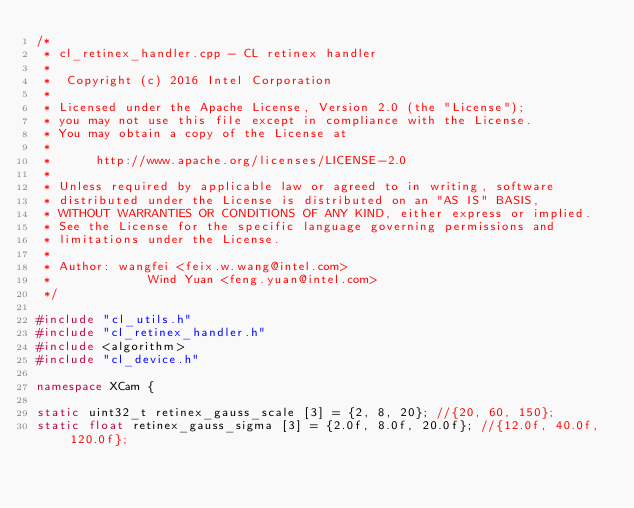<code> <loc_0><loc_0><loc_500><loc_500><_C++_>/*
 * cl_retinex_handler.cpp - CL retinex handler
 *
 *  Copyright (c) 2016 Intel Corporation
 *
 * Licensed under the Apache License, Version 2.0 (the "License");
 * you may not use this file except in compliance with the License.
 * You may obtain a copy of the License at
 *
 *      http://www.apache.org/licenses/LICENSE-2.0
 *
 * Unless required by applicable law or agreed to in writing, software
 * distributed under the License is distributed on an "AS IS" BASIS,
 * WITHOUT WARRANTIES OR CONDITIONS OF ANY KIND, either express or implied.
 * See the License for the specific language governing permissions and
 * limitations under the License.
 *
 * Author: wangfei <feix.w.wang@intel.com>
 *             Wind Yuan <feng.yuan@intel.com>
 */

#include "cl_utils.h"
#include "cl_retinex_handler.h"
#include <algorithm>
#include "cl_device.h"

namespace XCam {

static uint32_t retinex_gauss_scale [3] = {2, 8, 20}; //{20, 60, 150};
static float retinex_gauss_sigma [3] = {2.0f, 8.0f, 20.0f}; //{12.0f, 40.0f, 120.0f};</code> 